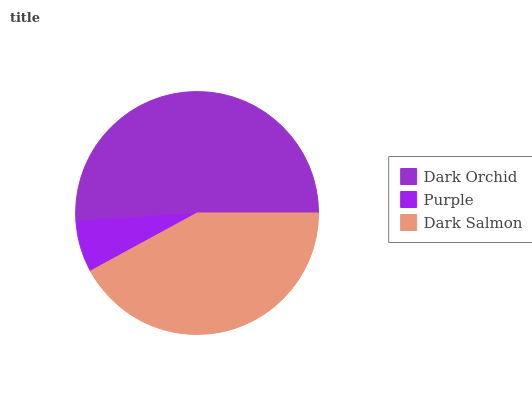Is Purple the minimum?
Answer yes or no. Yes. Is Dark Orchid the maximum?
Answer yes or no. Yes. Is Dark Salmon the minimum?
Answer yes or no. No. Is Dark Salmon the maximum?
Answer yes or no. No. Is Dark Salmon greater than Purple?
Answer yes or no. Yes. Is Purple less than Dark Salmon?
Answer yes or no. Yes. Is Purple greater than Dark Salmon?
Answer yes or no. No. Is Dark Salmon less than Purple?
Answer yes or no. No. Is Dark Salmon the high median?
Answer yes or no. Yes. Is Dark Salmon the low median?
Answer yes or no. Yes. Is Purple the high median?
Answer yes or no. No. Is Dark Orchid the low median?
Answer yes or no. No. 